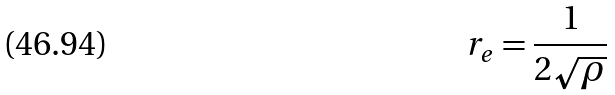Convert formula to latex. <formula><loc_0><loc_0><loc_500><loc_500>r _ { e } = \frac { 1 } { 2 \sqrt { \rho } }</formula> 